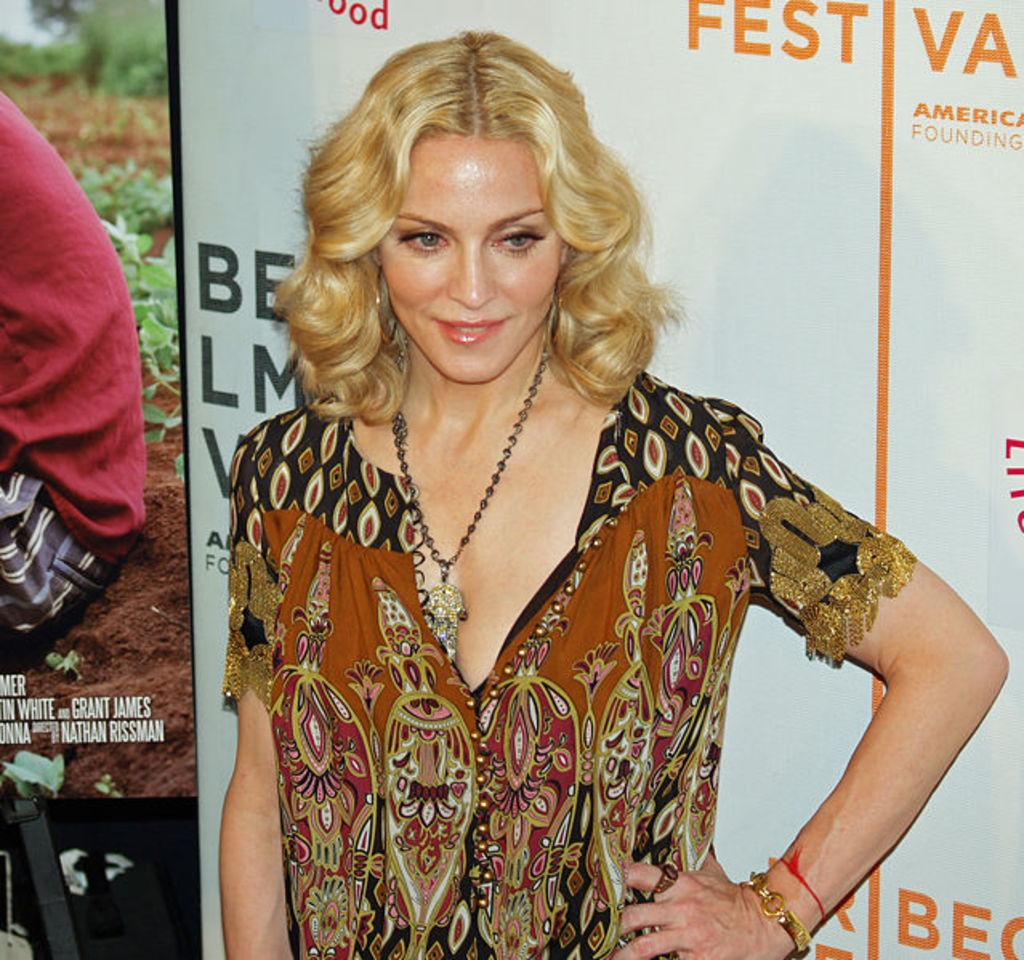What is the main subject of the image? There is a woman standing in the image. What can be seen in the background of the image? There are posters in the background of the image. What is featured on the posters? There is text on the posters. What type of pie is being served on the table in the image? There is no table or pie present in the image; it features a woman standing with posters in the background. What nerve is being stimulated by the image? The image does not stimulate any nerves; it is a visual representation of a woman standing with posters in the background. 